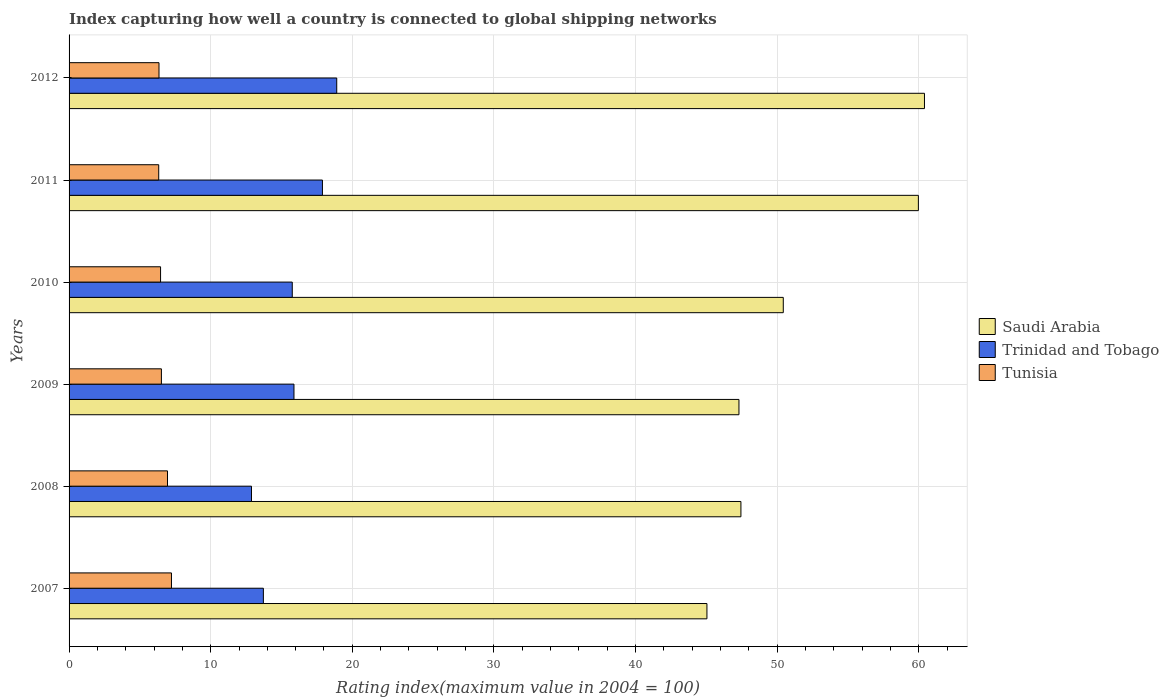How many different coloured bars are there?
Give a very brief answer. 3. Are the number of bars per tick equal to the number of legend labels?
Your response must be concise. Yes. How many bars are there on the 1st tick from the bottom?
Offer a terse response. 3. What is the rating index in Trinidad and Tobago in 2009?
Provide a short and direct response. 15.88. Across all years, what is the minimum rating index in Tunisia?
Your answer should be very brief. 6.33. What is the total rating index in Saudi Arabia in the graph?
Your response must be concise. 310.58. What is the difference between the rating index in Trinidad and Tobago in 2009 and that in 2010?
Ensure brevity in your answer.  0.12. What is the difference between the rating index in Tunisia in 2011 and the rating index in Saudi Arabia in 2012?
Keep it short and to the point. -54.07. What is the average rating index in Tunisia per year?
Offer a terse response. 6.64. In the year 2011, what is the difference between the rating index in Trinidad and Tobago and rating index in Saudi Arabia?
Offer a very short reply. -42.08. What is the ratio of the rating index in Trinidad and Tobago in 2007 to that in 2011?
Offer a very short reply. 0.77. Is the rating index in Saudi Arabia in 2007 less than that in 2012?
Make the answer very short. Yes. What is the difference between the highest and the second highest rating index in Saudi Arabia?
Your response must be concise. 0.43. What is the difference between the highest and the lowest rating index in Saudi Arabia?
Make the answer very short. 15.36. In how many years, is the rating index in Trinidad and Tobago greater than the average rating index in Trinidad and Tobago taken over all years?
Give a very brief answer. 3. What does the 3rd bar from the top in 2012 represents?
Make the answer very short. Saudi Arabia. What does the 2nd bar from the bottom in 2009 represents?
Give a very brief answer. Trinidad and Tobago. How many years are there in the graph?
Your answer should be very brief. 6. Does the graph contain any zero values?
Your answer should be compact. No. Does the graph contain grids?
Give a very brief answer. Yes. How are the legend labels stacked?
Offer a terse response. Vertical. What is the title of the graph?
Provide a succinct answer. Index capturing how well a country is connected to global shipping networks. Does "Slovak Republic" appear as one of the legend labels in the graph?
Provide a succinct answer. No. What is the label or title of the X-axis?
Give a very brief answer. Rating index(maximum value in 2004 = 100). What is the Rating index(maximum value in 2004 = 100) in Saudi Arabia in 2007?
Make the answer very short. 45.04. What is the Rating index(maximum value in 2004 = 100) of Trinidad and Tobago in 2007?
Ensure brevity in your answer.  13.72. What is the Rating index(maximum value in 2004 = 100) in Tunisia in 2007?
Your answer should be very brief. 7.23. What is the Rating index(maximum value in 2004 = 100) in Saudi Arabia in 2008?
Provide a succinct answer. 47.44. What is the Rating index(maximum value in 2004 = 100) in Trinidad and Tobago in 2008?
Your answer should be compact. 12.88. What is the Rating index(maximum value in 2004 = 100) of Tunisia in 2008?
Your answer should be very brief. 6.95. What is the Rating index(maximum value in 2004 = 100) in Saudi Arabia in 2009?
Provide a short and direct response. 47.3. What is the Rating index(maximum value in 2004 = 100) of Trinidad and Tobago in 2009?
Provide a short and direct response. 15.88. What is the Rating index(maximum value in 2004 = 100) in Tunisia in 2009?
Make the answer very short. 6.52. What is the Rating index(maximum value in 2004 = 100) in Saudi Arabia in 2010?
Your answer should be compact. 50.43. What is the Rating index(maximum value in 2004 = 100) in Trinidad and Tobago in 2010?
Give a very brief answer. 15.76. What is the Rating index(maximum value in 2004 = 100) of Tunisia in 2010?
Your response must be concise. 6.46. What is the Rating index(maximum value in 2004 = 100) in Saudi Arabia in 2011?
Provide a succinct answer. 59.97. What is the Rating index(maximum value in 2004 = 100) of Trinidad and Tobago in 2011?
Offer a terse response. 17.89. What is the Rating index(maximum value in 2004 = 100) in Tunisia in 2011?
Your answer should be compact. 6.33. What is the Rating index(maximum value in 2004 = 100) in Saudi Arabia in 2012?
Provide a succinct answer. 60.4. What is the Rating index(maximum value in 2004 = 100) in Tunisia in 2012?
Ensure brevity in your answer.  6.35. Across all years, what is the maximum Rating index(maximum value in 2004 = 100) in Saudi Arabia?
Offer a terse response. 60.4. Across all years, what is the maximum Rating index(maximum value in 2004 = 100) of Trinidad and Tobago?
Provide a succinct answer. 18.9. Across all years, what is the maximum Rating index(maximum value in 2004 = 100) in Tunisia?
Provide a succinct answer. 7.23. Across all years, what is the minimum Rating index(maximum value in 2004 = 100) of Saudi Arabia?
Offer a terse response. 45.04. Across all years, what is the minimum Rating index(maximum value in 2004 = 100) in Trinidad and Tobago?
Offer a very short reply. 12.88. Across all years, what is the minimum Rating index(maximum value in 2004 = 100) of Tunisia?
Your answer should be very brief. 6.33. What is the total Rating index(maximum value in 2004 = 100) in Saudi Arabia in the graph?
Make the answer very short. 310.58. What is the total Rating index(maximum value in 2004 = 100) in Trinidad and Tobago in the graph?
Ensure brevity in your answer.  95.03. What is the total Rating index(maximum value in 2004 = 100) in Tunisia in the graph?
Offer a terse response. 39.84. What is the difference between the Rating index(maximum value in 2004 = 100) in Trinidad and Tobago in 2007 and that in 2008?
Keep it short and to the point. 0.84. What is the difference between the Rating index(maximum value in 2004 = 100) in Tunisia in 2007 and that in 2008?
Give a very brief answer. 0.28. What is the difference between the Rating index(maximum value in 2004 = 100) of Saudi Arabia in 2007 and that in 2009?
Offer a very short reply. -2.26. What is the difference between the Rating index(maximum value in 2004 = 100) of Trinidad and Tobago in 2007 and that in 2009?
Make the answer very short. -2.16. What is the difference between the Rating index(maximum value in 2004 = 100) in Tunisia in 2007 and that in 2009?
Keep it short and to the point. 0.71. What is the difference between the Rating index(maximum value in 2004 = 100) in Saudi Arabia in 2007 and that in 2010?
Provide a short and direct response. -5.39. What is the difference between the Rating index(maximum value in 2004 = 100) in Trinidad and Tobago in 2007 and that in 2010?
Provide a succinct answer. -2.04. What is the difference between the Rating index(maximum value in 2004 = 100) in Tunisia in 2007 and that in 2010?
Make the answer very short. 0.77. What is the difference between the Rating index(maximum value in 2004 = 100) in Saudi Arabia in 2007 and that in 2011?
Your answer should be compact. -14.93. What is the difference between the Rating index(maximum value in 2004 = 100) of Trinidad and Tobago in 2007 and that in 2011?
Offer a terse response. -4.17. What is the difference between the Rating index(maximum value in 2004 = 100) in Tunisia in 2007 and that in 2011?
Your response must be concise. 0.9. What is the difference between the Rating index(maximum value in 2004 = 100) in Saudi Arabia in 2007 and that in 2012?
Your answer should be compact. -15.36. What is the difference between the Rating index(maximum value in 2004 = 100) in Trinidad and Tobago in 2007 and that in 2012?
Ensure brevity in your answer.  -5.18. What is the difference between the Rating index(maximum value in 2004 = 100) in Saudi Arabia in 2008 and that in 2009?
Ensure brevity in your answer.  0.14. What is the difference between the Rating index(maximum value in 2004 = 100) of Trinidad and Tobago in 2008 and that in 2009?
Give a very brief answer. -3. What is the difference between the Rating index(maximum value in 2004 = 100) in Tunisia in 2008 and that in 2009?
Provide a succinct answer. 0.43. What is the difference between the Rating index(maximum value in 2004 = 100) in Saudi Arabia in 2008 and that in 2010?
Keep it short and to the point. -2.99. What is the difference between the Rating index(maximum value in 2004 = 100) of Trinidad and Tobago in 2008 and that in 2010?
Provide a succinct answer. -2.88. What is the difference between the Rating index(maximum value in 2004 = 100) in Tunisia in 2008 and that in 2010?
Give a very brief answer. 0.49. What is the difference between the Rating index(maximum value in 2004 = 100) of Saudi Arabia in 2008 and that in 2011?
Make the answer very short. -12.53. What is the difference between the Rating index(maximum value in 2004 = 100) of Trinidad and Tobago in 2008 and that in 2011?
Give a very brief answer. -5.01. What is the difference between the Rating index(maximum value in 2004 = 100) in Tunisia in 2008 and that in 2011?
Keep it short and to the point. 0.62. What is the difference between the Rating index(maximum value in 2004 = 100) in Saudi Arabia in 2008 and that in 2012?
Offer a terse response. -12.96. What is the difference between the Rating index(maximum value in 2004 = 100) of Trinidad and Tobago in 2008 and that in 2012?
Your answer should be compact. -6.02. What is the difference between the Rating index(maximum value in 2004 = 100) in Tunisia in 2008 and that in 2012?
Your response must be concise. 0.6. What is the difference between the Rating index(maximum value in 2004 = 100) of Saudi Arabia in 2009 and that in 2010?
Your answer should be compact. -3.13. What is the difference between the Rating index(maximum value in 2004 = 100) in Trinidad and Tobago in 2009 and that in 2010?
Ensure brevity in your answer.  0.12. What is the difference between the Rating index(maximum value in 2004 = 100) of Tunisia in 2009 and that in 2010?
Ensure brevity in your answer.  0.06. What is the difference between the Rating index(maximum value in 2004 = 100) in Saudi Arabia in 2009 and that in 2011?
Your response must be concise. -12.67. What is the difference between the Rating index(maximum value in 2004 = 100) of Trinidad and Tobago in 2009 and that in 2011?
Your answer should be very brief. -2.01. What is the difference between the Rating index(maximum value in 2004 = 100) of Tunisia in 2009 and that in 2011?
Offer a very short reply. 0.19. What is the difference between the Rating index(maximum value in 2004 = 100) of Trinidad and Tobago in 2009 and that in 2012?
Offer a terse response. -3.02. What is the difference between the Rating index(maximum value in 2004 = 100) of Tunisia in 2009 and that in 2012?
Keep it short and to the point. 0.17. What is the difference between the Rating index(maximum value in 2004 = 100) in Saudi Arabia in 2010 and that in 2011?
Offer a terse response. -9.54. What is the difference between the Rating index(maximum value in 2004 = 100) in Trinidad and Tobago in 2010 and that in 2011?
Make the answer very short. -2.13. What is the difference between the Rating index(maximum value in 2004 = 100) of Tunisia in 2010 and that in 2011?
Offer a very short reply. 0.13. What is the difference between the Rating index(maximum value in 2004 = 100) of Saudi Arabia in 2010 and that in 2012?
Your answer should be very brief. -9.97. What is the difference between the Rating index(maximum value in 2004 = 100) of Trinidad and Tobago in 2010 and that in 2012?
Your answer should be very brief. -3.14. What is the difference between the Rating index(maximum value in 2004 = 100) in Tunisia in 2010 and that in 2012?
Your answer should be compact. 0.11. What is the difference between the Rating index(maximum value in 2004 = 100) in Saudi Arabia in 2011 and that in 2012?
Ensure brevity in your answer.  -0.43. What is the difference between the Rating index(maximum value in 2004 = 100) in Trinidad and Tobago in 2011 and that in 2012?
Give a very brief answer. -1.01. What is the difference between the Rating index(maximum value in 2004 = 100) of Tunisia in 2011 and that in 2012?
Offer a terse response. -0.02. What is the difference between the Rating index(maximum value in 2004 = 100) in Saudi Arabia in 2007 and the Rating index(maximum value in 2004 = 100) in Trinidad and Tobago in 2008?
Keep it short and to the point. 32.16. What is the difference between the Rating index(maximum value in 2004 = 100) in Saudi Arabia in 2007 and the Rating index(maximum value in 2004 = 100) in Tunisia in 2008?
Keep it short and to the point. 38.09. What is the difference between the Rating index(maximum value in 2004 = 100) of Trinidad and Tobago in 2007 and the Rating index(maximum value in 2004 = 100) of Tunisia in 2008?
Provide a short and direct response. 6.77. What is the difference between the Rating index(maximum value in 2004 = 100) in Saudi Arabia in 2007 and the Rating index(maximum value in 2004 = 100) in Trinidad and Tobago in 2009?
Offer a very short reply. 29.16. What is the difference between the Rating index(maximum value in 2004 = 100) of Saudi Arabia in 2007 and the Rating index(maximum value in 2004 = 100) of Tunisia in 2009?
Offer a terse response. 38.52. What is the difference between the Rating index(maximum value in 2004 = 100) in Trinidad and Tobago in 2007 and the Rating index(maximum value in 2004 = 100) in Tunisia in 2009?
Your answer should be very brief. 7.2. What is the difference between the Rating index(maximum value in 2004 = 100) of Saudi Arabia in 2007 and the Rating index(maximum value in 2004 = 100) of Trinidad and Tobago in 2010?
Give a very brief answer. 29.28. What is the difference between the Rating index(maximum value in 2004 = 100) of Saudi Arabia in 2007 and the Rating index(maximum value in 2004 = 100) of Tunisia in 2010?
Ensure brevity in your answer.  38.58. What is the difference between the Rating index(maximum value in 2004 = 100) of Trinidad and Tobago in 2007 and the Rating index(maximum value in 2004 = 100) of Tunisia in 2010?
Keep it short and to the point. 7.26. What is the difference between the Rating index(maximum value in 2004 = 100) in Saudi Arabia in 2007 and the Rating index(maximum value in 2004 = 100) in Trinidad and Tobago in 2011?
Offer a very short reply. 27.15. What is the difference between the Rating index(maximum value in 2004 = 100) in Saudi Arabia in 2007 and the Rating index(maximum value in 2004 = 100) in Tunisia in 2011?
Your response must be concise. 38.71. What is the difference between the Rating index(maximum value in 2004 = 100) in Trinidad and Tobago in 2007 and the Rating index(maximum value in 2004 = 100) in Tunisia in 2011?
Your response must be concise. 7.39. What is the difference between the Rating index(maximum value in 2004 = 100) in Saudi Arabia in 2007 and the Rating index(maximum value in 2004 = 100) in Trinidad and Tobago in 2012?
Make the answer very short. 26.14. What is the difference between the Rating index(maximum value in 2004 = 100) in Saudi Arabia in 2007 and the Rating index(maximum value in 2004 = 100) in Tunisia in 2012?
Give a very brief answer. 38.69. What is the difference between the Rating index(maximum value in 2004 = 100) of Trinidad and Tobago in 2007 and the Rating index(maximum value in 2004 = 100) of Tunisia in 2012?
Keep it short and to the point. 7.37. What is the difference between the Rating index(maximum value in 2004 = 100) of Saudi Arabia in 2008 and the Rating index(maximum value in 2004 = 100) of Trinidad and Tobago in 2009?
Make the answer very short. 31.56. What is the difference between the Rating index(maximum value in 2004 = 100) in Saudi Arabia in 2008 and the Rating index(maximum value in 2004 = 100) in Tunisia in 2009?
Give a very brief answer. 40.92. What is the difference between the Rating index(maximum value in 2004 = 100) of Trinidad and Tobago in 2008 and the Rating index(maximum value in 2004 = 100) of Tunisia in 2009?
Ensure brevity in your answer.  6.36. What is the difference between the Rating index(maximum value in 2004 = 100) in Saudi Arabia in 2008 and the Rating index(maximum value in 2004 = 100) in Trinidad and Tobago in 2010?
Ensure brevity in your answer.  31.68. What is the difference between the Rating index(maximum value in 2004 = 100) in Saudi Arabia in 2008 and the Rating index(maximum value in 2004 = 100) in Tunisia in 2010?
Your answer should be very brief. 40.98. What is the difference between the Rating index(maximum value in 2004 = 100) in Trinidad and Tobago in 2008 and the Rating index(maximum value in 2004 = 100) in Tunisia in 2010?
Provide a short and direct response. 6.42. What is the difference between the Rating index(maximum value in 2004 = 100) of Saudi Arabia in 2008 and the Rating index(maximum value in 2004 = 100) of Trinidad and Tobago in 2011?
Keep it short and to the point. 29.55. What is the difference between the Rating index(maximum value in 2004 = 100) of Saudi Arabia in 2008 and the Rating index(maximum value in 2004 = 100) of Tunisia in 2011?
Your answer should be compact. 41.11. What is the difference between the Rating index(maximum value in 2004 = 100) of Trinidad and Tobago in 2008 and the Rating index(maximum value in 2004 = 100) of Tunisia in 2011?
Provide a succinct answer. 6.55. What is the difference between the Rating index(maximum value in 2004 = 100) of Saudi Arabia in 2008 and the Rating index(maximum value in 2004 = 100) of Trinidad and Tobago in 2012?
Give a very brief answer. 28.54. What is the difference between the Rating index(maximum value in 2004 = 100) in Saudi Arabia in 2008 and the Rating index(maximum value in 2004 = 100) in Tunisia in 2012?
Offer a terse response. 41.09. What is the difference between the Rating index(maximum value in 2004 = 100) of Trinidad and Tobago in 2008 and the Rating index(maximum value in 2004 = 100) of Tunisia in 2012?
Your answer should be very brief. 6.53. What is the difference between the Rating index(maximum value in 2004 = 100) of Saudi Arabia in 2009 and the Rating index(maximum value in 2004 = 100) of Trinidad and Tobago in 2010?
Make the answer very short. 31.54. What is the difference between the Rating index(maximum value in 2004 = 100) of Saudi Arabia in 2009 and the Rating index(maximum value in 2004 = 100) of Tunisia in 2010?
Keep it short and to the point. 40.84. What is the difference between the Rating index(maximum value in 2004 = 100) of Trinidad and Tobago in 2009 and the Rating index(maximum value in 2004 = 100) of Tunisia in 2010?
Give a very brief answer. 9.42. What is the difference between the Rating index(maximum value in 2004 = 100) of Saudi Arabia in 2009 and the Rating index(maximum value in 2004 = 100) of Trinidad and Tobago in 2011?
Your answer should be very brief. 29.41. What is the difference between the Rating index(maximum value in 2004 = 100) of Saudi Arabia in 2009 and the Rating index(maximum value in 2004 = 100) of Tunisia in 2011?
Ensure brevity in your answer.  40.97. What is the difference between the Rating index(maximum value in 2004 = 100) of Trinidad and Tobago in 2009 and the Rating index(maximum value in 2004 = 100) of Tunisia in 2011?
Ensure brevity in your answer.  9.55. What is the difference between the Rating index(maximum value in 2004 = 100) in Saudi Arabia in 2009 and the Rating index(maximum value in 2004 = 100) in Trinidad and Tobago in 2012?
Ensure brevity in your answer.  28.4. What is the difference between the Rating index(maximum value in 2004 = 100) of Saudi Arabia in 2009 and the Rating index(maximum value in 2004 = 100) of Tunisia in 2012?
Your answer should be very brief. 40.95. What is the difference between the Rating index(maximum value in 2004 = 100) in Trinidad and Tobago in 2009 and the Rating index(maximum value in 2004 = 100) in Tunisia in 2012?
Keep it short and to the point. 9.53. What is the difference between the Rating index(maximum value in 2004 = 100) of Saudi Arabia in 2010 and the Rating index(maximum value in 2004 = 100) of Trinidad and Tobago in 2011?
Your response must be concise. 32.54. What is the difference between the Rating index(maximum value in 2004 = 100) in Saudi Arabia in 2010 and the Rating index(maximum value in 2004 = 100) in Tunisia in 2011?
Keep it short and to the point. 44.1. What is the difference between the Rating index(maximum value in 2004 = 100) in Trinidad and Tobago in 2010 and the Rating index(maximum value in 2004 = 100) in Tunisia in 2011?
Offer a terse response. 9.43. What is the difference between the Rating index(maximum value in 2004 = 100) in Saudi Arabia in 2010 and the Rating index(maximum value in 2004 = 100) in Trinidad and Tobago in 2012?
Provide a succinct answer. 31.53. What is the difference between the Rating index(maximum value in 2004 = 100) of Saudi Arabia in 2010 and the Rating index(maximum value in 2004 = 100) of Tunisia in 2012?
Keep it short and to the point. 44.08. What is the difference between the Rating index(maximum value in 2004 = 100) in Trinidad and Tobago in 2010 and the Rating index(maximum value in 2004 = 100) in Tunisia in 2012?
Make the answer very short. 9.41. What is the difference between the Rating index(maximum value in 2004 = 100) in Saudi Arabia in 2011 and the Rating index(maximum value in 2004 = 100) in Trinidad and Tobago in 2012?
Give a very brief answer. 41.07. What is the difference between the Rating index(maximum value in 2004 = 100) of Saudi Arabia in 2011 and the Rating index(maximum value in 2004 = 100) of Tunisia in 2012?
Ensure brevity in your answer.  53.62. What is the difference between the Rating index(maximum value in 2004 = 100) in Trinidad and Tobago in 2011 and the Rating index(maximum value in 2004 = 100) in Tunisia in 2012?
Give a very brief answer. 11.54. What is the average Rating index(maximum value in 2004 = 100) of Saudi Arabia per year?
Your answer should be compact. 51.76. What is the average Rating index(maximum value in 2004 = 100) of Trinidad and Tobago per year?
Ensure brevity in your answer.  15.84. What is the average Rating index(maximum value in 2004 = 100) in Tunisia per year?
Provide a succinct answer. 6.64. In the year 2007, what is the difference between the Rating index(maximum value in 2004 = 100) of Saudi Arabia and Rating index(maximum value in 2004 = 100) of Trinidad and Tobago?
Provide a succinct answer. 31.32. In the year 2007, what is the difference between the Rating index(maximum value in 2004 = 100) in Saudi Arabia and Rating index(maximum value in 2004 = 100) in Tunisia?
Provide a succinct answer. 37.81. In the year 2007, what is the difference between the Rating index(maximum value in 2004 = 100) of Trinidad and Tobago and Rating index(maximum value in 2004 = 100) of Tunisia?
Provide a short and direct response. 6.49. In the year 2008, what is the difference between the Rating index(maximum value in 2004 = 100) in Saudi Arabia and Rating index(maximum value in 2004 = 100) in Trinidad and Tobago?
Offer a very short reply. 34.56. In the year 2008, what is the difference between the Rating index(maximum value in 2004 = 100) of Saudi Arabia and Rating index(maximum value in 2004 = 100) of Tunisia?
Offer a terse response. 40.49. In the year 2008, what is the difference between the Rating index(maximum value in 2004 = 100) of Trinidad and Tobago and Rating index(maximum value in 2004 = 100) of Tunisia?
Your answer should be compact. 5.93. In the year 2009, what is the difference between the Rating index(maximum value in 2004 = 100) in Saudi Arabia and Rating index(maximum value in 2004 = 100) in Trinidad and Tobago?
Ensure brevity in your answer.  31.42. In the year 2009, what is the difference between the Rating index(maximum value in 2004 = 100) in Saudi Arabia and Rating index(maximum value in 2004 = 100) in Tunisia?
Ensure brevity in your answer.  40.78. In the year 2009, what is the difference between the Rating index(maximum value in 2004 = 100) in Trinidad and Tobago and Rating index(maximum value in 2004 = 100) in Tunisia?
Offer a terse response. 9.36. In the year 2010, what is the difference between the Rating index(maximum value in 2004 = 100) in Saudi Arabia and Rating index(maximum value in 2004 = 100) in Trinidad and Tobago?
Keep it short and to the point. 34.67. In the year 2010, what is the difference between the Rating index(maximum value in 2004 = 100) of Saudi Arabia and Rating index(maximum value in 2004 = 100) of Tunisia?
Make the answer very short. 43.97. In the year 2011, what is the difference between the Rating index(maximum value in 2004 = 100) in Saudi Arabia and Rating index(maximum value in 2004 = 100) in Trinidad and Tobago?
Offer a very short reply. 42.08. In the year 2011, what is the difference between the Rating index(maximum value in 2004 = 100) of Saudi Arabia and Rating index(maximum value in 2004 = 100) of Tunisia?
Your answer should be compact. 53.64. In the year 2011, what is the difference between the Rating index(maximum value in 2004 = 100) in Trinidad and Tobago and Rating index(maximum value in 2004 = 100) in Tunisia?
Provide a short and direct response. 11.56. In the year 2012, what is the difference between the Rating index(maximum value in 2004 = 100) of Saudi Arabia and Rating index(maximum value in 2004 = 100) of Trinidad and Tobago?
Keep it short and to the point. 41.5. In the year 2012, what is the difference between the Rating index(maximum value in 2004 = 100) in Saudi Arabia and Rating index(maximum value in 2004 = 100) in Tunisia?
Your answer should be very brief. 54.05. In the year 2012, what is the difference between the Rating index(maximum value in 2004 = 100) in Trinidad and Tobago and Rating index(maximum value in 2004 = 100) in Tunisia?
Give a very brief answer. 12.55. What is the ratio of the Rating index(maximum value in 2004 = 100) of Saudi Arabia in 2007 to that in 2008?
Keep it short and to the point. 0.95. What is the ratio of the Rating index(maximum value in 2004 = 100) of Trinidad and Tobago in 2007 to that in 2008?
Offer a terse response. 1.07. What is the ratio of the Rating index(maximum value in 2004 = 100) in Tunisia in 2007 to that in 2008?
Make the answer very short. 1.04. What is the ratio of the Rating index(maximum value in 2004 = 100) of Saudi Arabia in 2007 to that in 2009?
Provide a short and direct response. 0.95. What is the ratio of the Rating index(maximum value in 2004 = 100) of Trinidad and Tobago in 2007 to that in 2009?
Provide a succinct answer. 0.86. What is the ratio of the Rating index(maximum value in 2004 = 100) in Tunisia in 2007 to that in 2009?
Your response must be concise. 1.11. What is the ratio of the Rating index(maximum value in 2004 = 100) of Saudi Arabia in 2007 to that in 2010?
Offer a terse response. 0.89. What is the ratio of the Rating index(maximum value in 2004 = 100) of Trinidad and Tobago in 2007 to that in 2010?
Give a very brief answer. 0.87. What is the ratio of the Rating index(maximum value in 2004 = 100) in Tunisia in 2007 to that in 2010?
Offer a terse response. 1.12. What is the ratio of the Rating index(maximum value in 2004 = 100) of Saudi Arabia in 2007 to that in 2011?
Offer a very short reply. 0.75. What is the ratio of the Rating index(maximum value in 2004 = 100) of Trinidad and Tobago in 2007 to that in 2011?
Ensure brevity in your answer.  0.77. What is the ratio of the Rating index(maximum value in 2004 = 100) of Tunisia in 2007 to that in 2011?
Keep it short and to the point. 1.14. What is the ratio of the Rating index(maximum value in 2004 = 100) in Saudi Arabia in 2007 to that in 2012?
Ensure brevity in your answer.  0.75. What is the ratio of the Rating index(maximum value in 2004 = 100) in Trinidad and Tobago in 2007 to that in 2012?
Offer a terse response. 0.73. What is the ratio of the Rating index(maximum value in 2004 = 100) in Tunisia in 2007 to that in 2012?
Keep it short and to the point. 1.14. What is the ratio of the Rating index(maximum value in 2004 = 100) of Saudi Arabia in 2008 to that in 2009?
Ensure brevity in your answer.  1. What is the ratio of the Rating index(maximum value in 2004 = 100) of Trinidad and Tobago in 2008 to that in 2009?
Make the answer very short. 0.81. What is the ratio of the Rating index(maximum value in 2004 = 100) in Tunisia in 2008 to that in 2009?
Make the answer very short. 1.07. What is the ratio of the Rating index(maximum value in 2004 = 100) in Saudi Arabia in 2008 to that in 2010?
Provide a short and direct response. 0.94. What is the ratio of the Rating index(maximum value in 2004 = 100) of Trinidad and Tobago in 2008 to that in 2010?
Ensure brevity in your answer.  0.82. What is the ratio of the Rating index(maximum value in 2004 = 100) in Tunisia in 2008 to that in 2010?
Give a very brief answer. 1.08. What is the ratio of the Rating index(maximum value in 2004 = 100) of Saudi Arabia in 2008 to that in 2011?
Ensure brevity in your answer.  0.79. What is the ratio of the Rating index(maximum value in 2004 = 100) in Trinidad and Tobago in 2008 to that in 2011?
Provide a short and direct response. 0.72. What is the ratio of the Rating index(maximum value in 2004 = 100) in Tunisia in 2008 to that in 2011?
Your response must be concise. 1.1. What is the ratio of the Rating index(maximum value in 2004 = 100) of Saudi Arabia in 2008 to that in 2012?
Keep it short and to the point. 0.79. What is the ratio of the Rating index(maximum value in 2004 = 100) of Trinidad and Tobago in 2008 to that in 2012?
Provide a succinct answer. 0.68. What is the ratio of the Rating index(maximum value in 2004 = 100) in Tunisia in 2008 to that in 2012?
Offer a terse response. 1.09. What is the ratio of the Rating index(maximum value in 2004 = 100) of Saudi Arabia in 2009 to that in 2010?
Your response must be concise. 0.94. What is the ratio of the Rating index(maximum value in 2004 = 100) in Trinidad and Tobago in 2009 to that in 2010?
Make the answer very short. 1.01. What is the ratio of the Rating index(maximum value in 2004 = 100) of Tunisia in 2009 to that in 2010?
Make the answer very short. 1.01. What is the ratio of the Rating index(maximum value in 2004 = 100) in Saudi Arabia in 2009 to that in 2011?
Provide a succinct answer. 0.79. What is the ratio of the Rating index(maximum value in 2004 = 100) in Trinidad and Tobago in 2009 to that in 2011?
Provide a short and direct response. 0.89. What is the ratio of the Rating index(maximum value in 2004 = 100) in Saudi Arabia in 2009 to that in 2012?
Keep it short and to the point. 0.78. What is the ratio of the Rating index(maximum value in 2004 = 100) of Trinidad and Tobago in 2009 to that in 2012?
Your response must be concise. 0.84. What is the ratio of the Rating index(maximum value in 2004 = 100) in Tunisia in 2009 to that in 2012?
Your answer should be compact. 1.03. What is the ratio of the Rating index(maximum value in 2004 = 100) of Saudi Arabia in 2010 to that in 2011?
Make the answer very short. 0.84. What is the ratio of the Rating index(maximum value in 2004 = 100) in Trinidad and Tobago in 2010 to that in 2011?
Offer a very short reply. 0.88. What is the ratio of the Rating index(maximum value in 2004 = 100) of Tunisia in 2010 to that in 2011?
Give a very brief answer. 1.02. What is the ratio of the Rating index(maximum value in 2004 = 100) in Saudi Arabia in 2010 to that in 2012?
Your response must be concise. 0.83. What is the ratio of the Rating index(maximum value in 2004 = 100) in Trinidad and Tobago in 2010 to that in 2012?
Provide a succinct answer. 0.83. What is the ratio of the Rating index(maximum value in 2004 = 100) in Tunisia in 2010 to that in 2012?
Your response must be concise. 1.02. What is the ratio of the Rating index(maximum value in 2004 = 100) of Saudi Arabia in 2011 to that in 2012?
Provide a succinct answer. 0.99. What is the ratio of the Rating index(maximum value in 2004 = 100) of Trinidad and Tobago in 2011 to that in 2012?
Provide a succinct answer. 0.95. What is the difference between the highest and the second highest Rating index(maximum value in 2004 = 100) in Saudi Arabia?
Give a very brief answer. 0.43. What is the difference between the highest and the second highest Rating index(maximum value in 2004 = 100) of Trinidad and Tobago?
Keep it short and to the point. 1.01. What is the difference between the highest and the second highest Rating index(maximum value in 2004 = 100) in Tunisia?
Keep it short and to the point. 0.28. What is the difference between the highest and the lowest Rating index(maximum value in 2004 = 100) in Saudi Arabia?
Offer a terse response. 15.36. What is the difference between the highest and the lowest Rating index(maximum value in 2004 = 100) of Trinidad and Tobago?
Keep it short and to the point. 6.02. What is the difference between the highest and the lowest Rating index(maximum value in 2004 = 100) in Tunisia?
Ensure brevity in your answer.  0.9. 